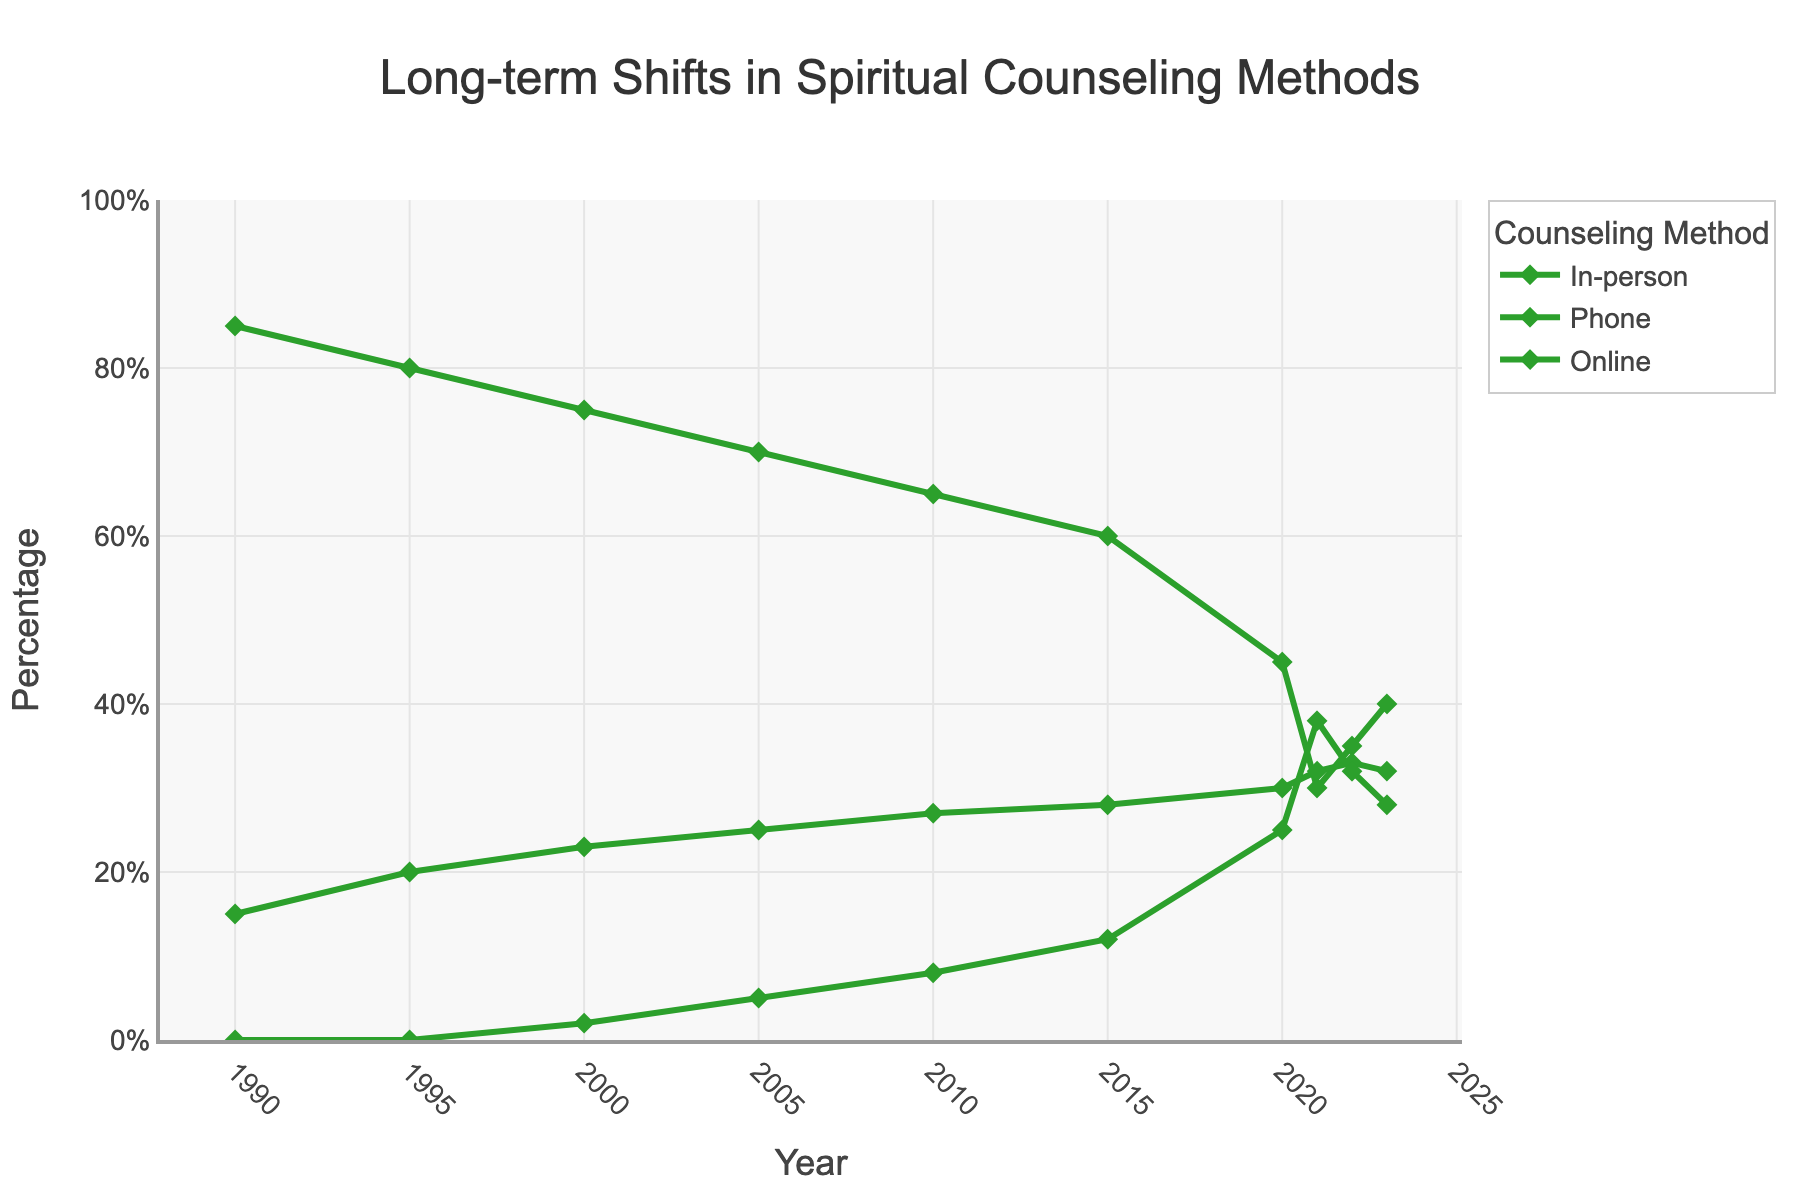what does the shift in preference from in-person counseling in 1990 to 2023 tell you? In 1990, 85% of counseling was in-person, declining to 40% by 2023. This trend indicates a significant decrease in preference for in-person counseling, reflecting changing dynamics in how members seek guidance.
Answer: Decrease in preference for in-person counseling Which year shows the highest percentage of people preferring online counseling? Looking at the line representing online counseling, the peak occurs in 2021, where it reaches its highest point.
Answer: 2021 What is the combined percentage of people preferring phone and online counseling methods in 2023? In 2023, 32% prefer phone counseling and 28% prefer online counseling. Adding these together: 32 + 28 = 60.
Answer: 60% How does the percentage of people preferring phone counseling in 2023 compare to that in 1990? In 1990, the preference for phone counseling was at 15%, and by 2023, it increased to 32%. This shows a significant rise.
Answer: Increased by 17% Which period saw the most rapid increase in online counseling preference? Examining the line chart, the steepest increase in online counseling preference occurs between 2020 and 2021.
Answer: 2020 to 2021 What changes in the trend of in-person counseling are observed from 2010 to 2023? From 2010 to 2023, in-person counseling shows a consistent decline, dropping significantly from 65% to 40%.
Answer: Decline from 65% to 40% How does the preference for phone counseling in 2010 compare to the preference for online counseling in 2022? In 2010, phone counseling was preferred by 27% of members, while in 2022, online counseling was preferred by 32%.
Answer: Online counseling in 2022 was preferred more What is the difference in the percentage of members preferring in-person and online counseling in the year 2000? In 2000, 75% preferred in-person, and 2% preferred online. The difference is 75 - 2 = 73.
Answer: 73% What trend is seen in the preferences for online counseling from 2010 to 2023? From 2010 to 2023, there is a noticeable upward trend in the preference for online counseling, increasing from 8% to 28%.
Answer: Upward trend During which decade did in-person counseling see the steepest decline? Observing the in-person counseling line, the steepest decline happens between 2010 and 2020.
Answer: 2010 to 2020 